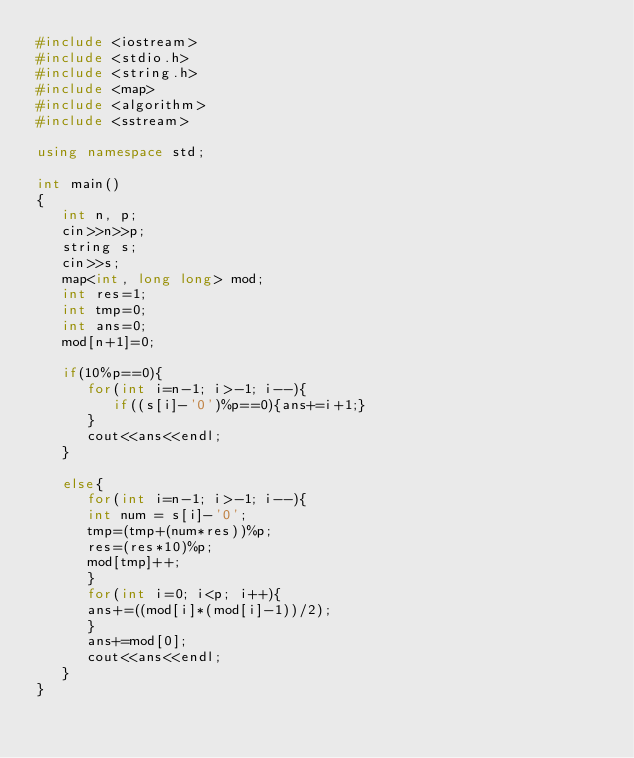<code> <loc_0><loc_0><loc_500><loc_500><_C++_>#include <iostream>
#include <stdio.h>
#include <string.h>
#include <map>
#include <algorithm>
#include <sstream>

using namespace std;

int main()
{
   int n, p;
   cin>>n>>p;
   string s;
   cin>>s;
   map<int, long long> mod;
   int res=1;
   int tmp=0;
   int ans=0;
   mod[n+1]=0;

   if(10%p==0){
      for(int i=n-1; i>-1; i--){
         if((s[i]-'0')%p==0){ans+=i+1;}
      }
      cout<<ans<<endl;
   }

   else{
      for(int i=n-1; i>-1; i--){
      int num = s[i]-'0';
      tmp=(tmp+(num*res))%p;
      res=(res*10)%p;
      mod[tmp]++;
      }
      for(int i=0; i<p; i++){
      ans+=((mod[i]*(mod[i]-1))/2);
      }
      ans+=mod[0];
      cout<<ans<<endl;
   }
}
</code> 